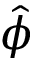Convert formula to latex. <formula><loc_0><loc_0><loc_500><loc_500>\hat { \phi }</formula> 